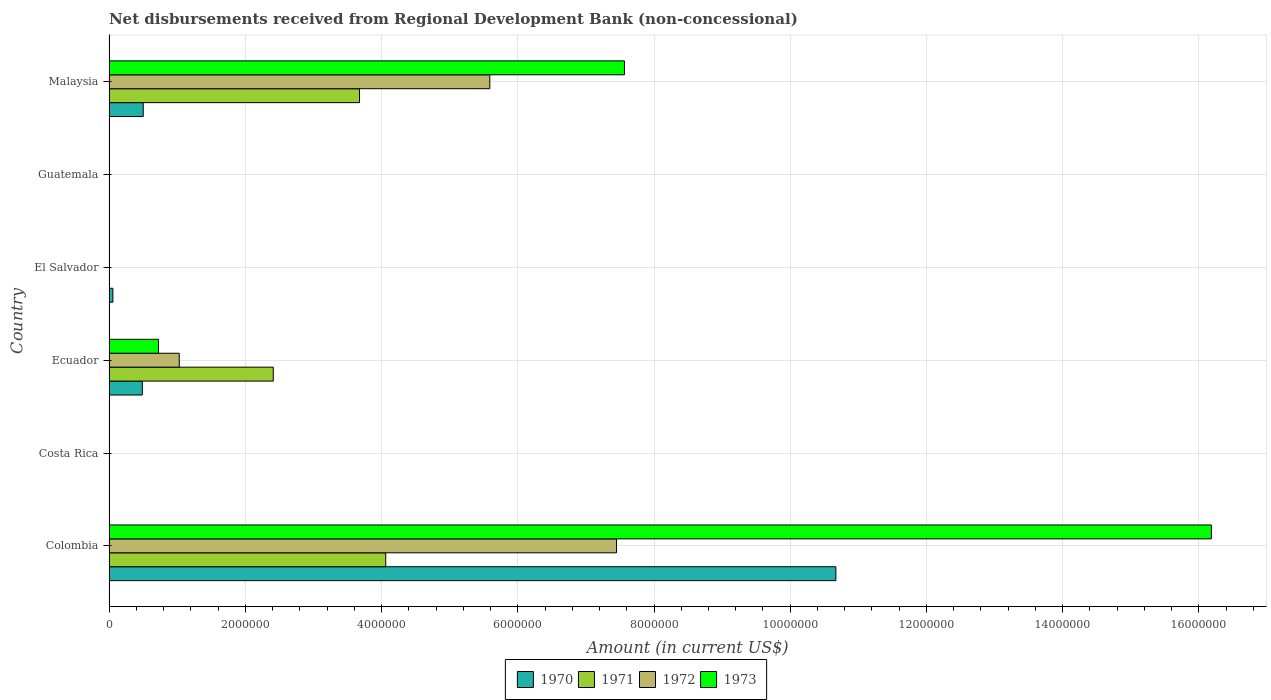Are the number of bars on each tick of the Y-axis equal?
Provide a succinct answer. No. How many bars are there on the 1st tick from the top?
Your response must be concise. 4. What is the label of the 4th group of bars from the top?
Keep it short and to the point. Ecuador. Across all countries, what is the maximum amount of disbursements received from Regional Development Bank in 1973?
Provide a short and direct response. 1.62e+07. What is the total amount of disbursements received from Regional Development Bank in 1971 in the graph?
Keep it short and to the point. 1.02e+07. What is the difference between the amount of disbursements received from Regional Development Bank in 1972 in Malaysia and the amount of disbursements received from Regional Development Bank in 1970 in Costa Rica?
Offer a very short reply. 5.59e+06. What is the average amount of disbursements received from Regional Development Bank in 1972 per country?
Your answer should be very brief. 2.35e+06. What is the difference between the amount of disbursements received from Regional Development Bank in 1972 and amount of disbursements received from Regional Development Bank in 1973 in Ecuador?
Provide a succinct answer. 3.05e+05. In how many countries, is the amount of disbursements received from Regional Development Bank in 1971 greater than 8400000 US$?
Your response must be concise. 0. What is the ratio of the amount of disbursements received from Regional Development Bank in 1972 in Colombia to that in Ecuador?
Your answer should be very brief. 7.23. Is the amount of disbursements received from Regional Development Bank in 1971 in Ecuador less than that in Malaysia?
Offer a terse response. Yes. Is the difference between the amount of disbursements received from Regional Development Bank in 1972 in Colombia and Ecuador greater than the difference between the amount of disbursements received from Regional Development Bank in 1973 in Colombia and Ecuador?
Provide a succinct answer. No. What is the difference between the highest and the second highest amount of disbursements received from Regional Development Bank in 1970?
Offer a very short reply. 1.02e+07. What is the difference between the highest and the lowest amount of disbursements received from Regional Development Bank in 1973?
Provide a succinct answer. 1.62e+07. How many bars are there?
Your answer should be very brief. 13. Are all the bars in the graph horizontal?
Your response must be concise. Yes. How many countries are there in the graph?
Make the answer very short. 6. Does the graph contain any zero values?
Make the answer very short. Yes. Where does the legend appear in the graph?
Your answer should be compact. Bottom center. How many legend labels are there?
Offer a terse response. 4. What is the title of the graph?
Offer a very short reply. Net disbursements received from Regional Development Bank (non-concessional). What is the label or title of the X-axis?
Provide a short and direct response. Amount (in current US$). What is the Amount (in current US$) in 1970 in Colombia?
Offer a very short reply. 1.07e+07. What is the Amount (in current US$) of 1971 in Colombia?
Your answer should be very brief. 4.06e+06. What is the Amount (in current US$) of 1972 in Colombia?
Your answer should be very brief. 7.45e+06. What is the Amount (in current US$) in 1973 in Colombia?
Make the answer very short. 1.62e+07. What is the Amount (in current US$) in 1970 in Costa Rica?
Offer a terse response. 0. What is the Amount (in current US$) in 1971 in Costa Rica?
Provide a succinct answer. 0. What is the Amount (in current US$) of 1972 in Costa Rica?
Your response must be concise. 0. What is the Amount (in current US$) of 1973 in Costa Rica?
Ensure brevity in your answer.  0. What is the Amount (in current US$) of 1970 in Ecuador?
Give a very brief answer. 4.89e+05. What is the Amount (in current US$) of 1971 in Ecuador?
Keep it short and to the point. 2.41e+06. What is the Amount (in current US$) of 1972 in Ecuador?
Make the answer very short. 1.03e+06. What is the Amount (in current US$) in 1973 in Ecuador?
Offer a terse response. 7.26e+05. What is the Amount (in current US$) in 1970 in El Salvador?
Provide a succinct answer. 5.70e+04. What is the Amount (in current US$) in 1971 in El Salvador?
Ensure brevity in your answer.  0. What is the Amount (in current US$) of 1970 in Guatemala?
Your answer should be compact. 0. What is the Amount (in current US$) in 1971 in Guatemala?
Ensure brevity in your answer.  0. What is the Amount (in current US$) in 1970 in Malaysia?
Your answer should be very brief. 5.02e+05. What is the Amount (in current US$) in 1971 in Malaysia?
Provide a succinct answer. 3.68e+06. What is the Amount (in current US$) in 1972 in Malaysia?
Provide a short and direct response. 5.59e+06. What is the Amount (in current US$) in 1973 in Malaysia?
Your answer should be very brief. 7.57e+06. Across all countries, what is the maximum Amount (in current US$) of 1970?
Your answer should be compact. 1.07e+07. Across all countries, what is the maximum Amount (in current US$) in 1971?
Offer a terse response. 4.06e+06. Across all countries, what is the maximum Amount (in current US$) in 1972?
Your response must be concise. 7.45e+06. Across all countries, what is the maximum Amount (in current US$) in 1973?
Your answer should be very brief. 1.62e+07. Across all countries, what is the minimum Amount (in current US$) in 1970?
Offer a very short reply. 0. What is the total Amount (in current US$) of 1970 in the graph?
Your answer should be compact. 1.17e+07. What is the total Amount (in current US$) of 1971 in the graph?
Ensure brevity in your answer.  1.02e+07. What is the total Amount (in current US$) of 1972 in the graph?
Give a very brief answer. 1.41e+07. What is the total Amount (in current US$) in 1973 in the graph?
Provide a succinct answer. 2.45e+07. What is the difference between the Amount (in current US$) in 1970 in Colombia and that in Ecuador?
Give a very brief answer. 1.02e+07. What is the difference between the Amount (in current US$) of 1971 in Colombia and that in Ecuador?
Offer a terse response. 1.65e+06. What is the difference between the Amount (in current US$) of 1972 in Colombia and that in Ecuador?
Offer a very short reply. 6.42e+06. What is the difference between the Amount (in current US$) of 1973 in Colombia and that in Ecuador?
Ensure brevity in your answer.  1.55e+07. What is the difference between the Amount (in current US$) of 1970 in Colombia and that in El Salvador?
Provide a succinct answer. 1.06e+07. What is the difference between the Amount (in current US$) of 1970 in Colombia and that in Malaysia?
Your answer should be compact. 1.02e+07. What is the difference between the Amount (in current US$) of 1971 in Colombia and that in Malaysia?
Keep it short and to the point. 3.85e+05. What is the difference between the Amount (in current US$) of 1972 in Colombia and that in Malaysia?
Offer a terse response. 1.86e+06. What is the difference between the Amount (in current US$) in 1973 in Colombia and that in Malaysia?
Ensure brevity in your answer.  8.62e+06. What is the difference between the Amount (in current US$) of 1970 in Ecuador and that in El Salvador?
Your answer should be compact. 4.32e+05. What is the difference between the Amount (in current US$) of 1970 in Ecuador and that in Malaysia?
Your answer should be very brief. -1.30e+04. What is the difference between the Amount (in current US$) in 1971 in Ecuador and that in Malaysia?
Provide a short and direct response. -1.27e+06. What is the difference between the Amount (in current US$) of 1972 in Ecuador and that in Malaysia?
Keep it short and to the point. -4.56e+06. What is the difference between the Amount (in current US$) in 1973 in Ecuador and that in Malaysia?
Make the answer very short. -6.84e+06. What is the difference between the Amount (in current US$) in 1970 in El Salvador and that in Malaysia?
Your response must be concise. -4.45e+05. What is the difference between the Amount (in current US$) in 1970 in Colombia and the Amount (in current US$) in 1971 in Ecuador?
Ensure brevity in your answer.  8.26e+06. What is the difference between the Amount (in current US$) of 1970 in Colombia and the Amount (in current US$) of 1972 in Ecuador?
Provide a short and direct response. 9.64e+06. What is the difference between the Amount (in current US$) of 1970 in Colombia and the Amount (in current US$) of 1973 in Ecuador?
Ensure brevity in your answer.  9.94e+06. What is the difference between the Amount (in current US$) of 1971 in Colombia and the Amount (in current US$) of 1972 in Ecuador?
Your answer should be compact. 3.03e+06. What is the difference between the Amount (in current US$) in 1971 in Colombia and the Amount (in current US$) in 1973 in Ecuador?
Provide a succinct answer. 3.34e+06. What is the difference between the Amount (in current US$) in 1972 in Colombia and the Amount (in current US$) in 1973 in Ecuador?
Provide a succinct answer. 6.72e+06. What is the difference between the Amount (in current US$) in 1970 in Colombia and the Amount (in current US$) in 1971 in Malaysia?
Provide a short and direct response. 6.99e+06. What is the difference between the Amount (in current US$) of 1970 in Colombia and the Amount (in current US$) of 1972 in Malaysia?
Your response must be concise. 5.08e+06. What is the difference between the Amount (in current US$) of 1970 in Colombia and the Amount (in current US$) of 1973 in Malaysia?
Provide a short and direct response. 3.10e+06. What is the difference between the Amount (in current US$) of 1971 in Colombia and the Amount (in current US$) of 1972 in Malaysia?
Your response must be concise. -1.53e+06. What is the difference between the Amount (in current US$) of 1971 in Colombia and the Amount (in current US$) of 1973 in Malaysia?
Provide a succinct answer. -3.50e+06. What is the difference between the Amount (in current US$) in 1972 in Colombia and the Amount (in current US$) in 1973 in Malaysia?
Your response must be concise. -1.16e+05. What is the difference between the Amount (in current US$) in 1970 in Ecuador and the Amount (in current US$) in 1971 in Malaysia?
Your answer should be very brief. -3.19e+06. What is the difference between the Amount (in current US$) in 1970 in Ecuador and the Amount (in current US$) in 1972 in Malaysia?
Offer a very short reply. -5.10e+06. What is the difference between the Amount (in current US$) of 1970 in Ecuador and the Amount (in current US$) of 1973 in Malaysia?
Provide a succinct answer. -7.08e+06. What is the difference between the Amount (in current US$) of 1971 in Ecuador and the Amount (in current US$) of 1972 in Malaysia?
Provide a succinct answer. -3.18e+06. What is the difference between the Amount (in current US$) of 1971 in Ecuador and the Amount (in current US$) of 1973 in Malaysia?
Offer a terse response. -5.16e+06. What is the difference between the Amount (in current US$) of 1972 in Ecuador and the Amount (in current US$) of 1973 in Malaysia?
Your response must be concise. -6.54e+06. What is the difference between the Amount (in current US$) of 1970 in El Salvador and the Amount (in current US$) of 1971 in Malaysia?
Your answer should be compact. -3.62e+06. What is the difference between the Amount (in current US$) in 1970 in El Salvador and the Amount (in current US$) in 1972 in Malaysia?
Make the answer very short. -5.53e+06. What is the difference between the Amount (in current US$) of 1970 in El Salvador and the Amount (in current US$) of 1973 in Malaysia?
Provide a short and direct response. -7.51e+06. What is the average Amount (in current US$) of 1970 per country?
Keep it short and to the point. 1.95e+06. What is the average Amount (in current US$) in 1971 per country?
Keep it short and to the point. 1.69e+06. What is the average Amount (in current US$) in 1972 per country?
Provide a succinct answer. 2.35e+06. What is the average Amount (in current US$) in 1973 per country?
Give a very brief answer. 4.08e+06. What is the difference between the Amount (in current US$) of 1970 and Amount (in current US$) of 1971 in Colombia?
Offer a terse response. 6.61e+06. What is the difference between the Amount (in current US$) in 1970 and Amount (in current US$) in 1972 in Colombia?
Keep it short and to the point. 3.22e+06. What is the difference between the Amount (in current US$) of 1970 and Amount (in current US$) of 1973 in Colombia?
Your response must be concise. -5.51e+06. What is the difference between the Amount (in current US$) in 1971 and Amount (in current US$) in 1972 in Colombia?
Ensure brevity in your answer.  -3.39e+06. What is the difference between the Amount (in current US$) in 1971 and Amount (in current US$) in 1973 in Colombia?
Your answer should be compact. -1.21e+07. What is the difference between the Amount (in current US$) of 1972 and Amount (in current US$) of 1973 in Colombia?
Offer a very short reply. -8.73e+06. What is the difference between the Amount (in current US$) in 1970 and Amount (in current US$) in 1971 in Ecuador?
Make the answer very short. -1.92e+06. What is the difference between the Amount (in current US$) in 1970 and Amount (in current US$) in 1972 in Ecuador?
Your answer should be compact. -5.42e+05. What is the difference between the Amount (in current US$) in 1970 and Amount (in current US$) in 1973 in Ecuador?
Your answer should be very brief. -2.37e+05. What is the difference between the Amount (in current US$) of 1971 and Amount (in current US$) of 1972 in Ecuador?
Your answer should be very brief. 1.38e+06. What is the difference between the Amount (in current US$) in 1971 and Amount (in current US$) in 1973 in Ecuador?
Keep it short and to the point. 1.68e+06. What is the difference between the Amount (in current US$) of 1972 and Amount (in current US$) of 1973 in Ecuador?
Make the answer very short. 3.05e+05. What is the difference between the Amount (in current US$) in 1970 and Amount (in current US$) in 1971 in Malaysia?
Offer a very short reply. -3.18e+06. What is the difference between the Amount (in current US$) in 1970 and Amount (in current US$) in 1972 in Malaysia?
Offer a terse response. -5.09e+06. What is the difference between the Amount (in current US$) of 1970 and Amount (in current US$) of 1973 in Malaysia?
Provide a succinct answer. -7.06e+06. What is the difference between the Amount (in current US$) in 1971 and Amount (in current US$) in 1972 in Malaysia?
Your answer should be very brief. -1.91e+06. What is the difference between the Amount (in current US$) in 1971 and Amount (in current US$) in 1973 in Malaysia?
Offer a terse response. -3.89e+06. What is the difference between the Amount (in current US$) of 1972 and Amount (in current US$) of 1973 in Malaysia?
Give a very brief answer. -1.98e+06. What is the ratio of the Amount (in current US$) of 1970 in Colombia to that in Ecuador?
Give a very brief answer. 21.82. What is the ratio of the Amount (in current US$) of 1971 in Colombia to that in Ecuador?
Give a very brief answer. 1.68. What is the ratio of the Amount (in current US$) of 1972 in Colombia to that in Ecuador?
Keep it short and to the point. 7.23. What is the ratio of the Amount (in current US$) in 1973 in Colombia to that in Ecuador?
Offer a very short reply. 22.29. What is the ratio of the Amount (in current US$) in 1970 in Colombia to that in El Salvador?
Offer a terse response. 187.19. What is the ratio of the Amount (in current US$) of 1970 in Colombia to that in Malaysia?
Keep it short and to the point. 21.25. What is the ratio of the Amount (in current US$) in 1971 in Colombia to that in Malaysia?
Keep it short and to the point. 1.1. What is the ratio of the Amount (in current US$) of 1972 in Colombia to that in Malaysia?
Provide a short and direct response. 1.33. What is the ratio of the Amount (in current US$) in 1973 in Colombia to that in Malaysia?
Ensure brevity in your answer.  2.14. What is the ratio of the Amount (in current US$) in 1970 in Ecuador to that in El Salvador?
Your answer should be very brief. 8.58. What is the ratio of the Amount (in current US$) in 1970 in Ecuador to that in Malaysia?
Keep it short and to the point. 0.97. What is the ratio of the Amount (in current US$) of 1971 in Ecuador to that in Malaysia?
Ensure brevity in your answer.  0.66. What is the ratio of the Amount (in current US$) in 1972 in Ecuador to that in Malaysia?
Make the answer very short. 0.18. What is the ratio of the Amount (in current US$) of 1973 in Ecuador to that in Malaysia?
Provide a succinct answer. 0.1. What is the ratio of the Amount (in current US$) in 1970 in El Salvador to that in Malaysia?
Give a very brief answer. 0.11. What is the difference between the highest and the second highest Amount (in current US$) in 1970?
Keep it short and to the point. 1.02e+07. What is the difference between the highest and the second highest Amount (in current US$) in 1971?
Offer a very short reply. 3.85e+05. What is the difference between the highest and the second highest Amount (in current US$) in 1972?
Ensure brevity in your answer.  1.86e+06. What is the difference between the highest and the second highest Amount (in current US$) of 1973?
Provide a succinct answer. 8.62e+06. What is the difference between the highest and the lowest Amount (in current US$) of 1970?
Offer a very short reply. 1.07e+07. What is the difference between the highest and the lowest Amount (in current US$) of 1971?
Ensure brevity in your answer.  4.06e+06. What is the difference between the highest and the lowest Amount (in current US$) in 1972?
Offer a very short reply. 7.45e+06. What is the difference between the highest and the lowest Amount (in current US$) of 1973?
Provide a short and direct response. 1.62e+07. 